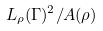Convert formula to latex. <formula><loc_0><loc_0><loc_500><loc_500>L _ { \rho } ( \Gamma ) ^ { 2 } / A ( \rho )</formula> 